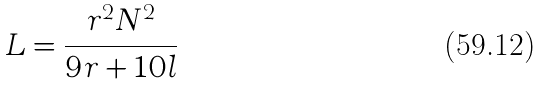<formula> <loc_0><loc_0><loc_500><loc_500>L = \frac { r ^ { 2 } N ^ { 2 } } { 9 r + 1 0 l }</formula> 